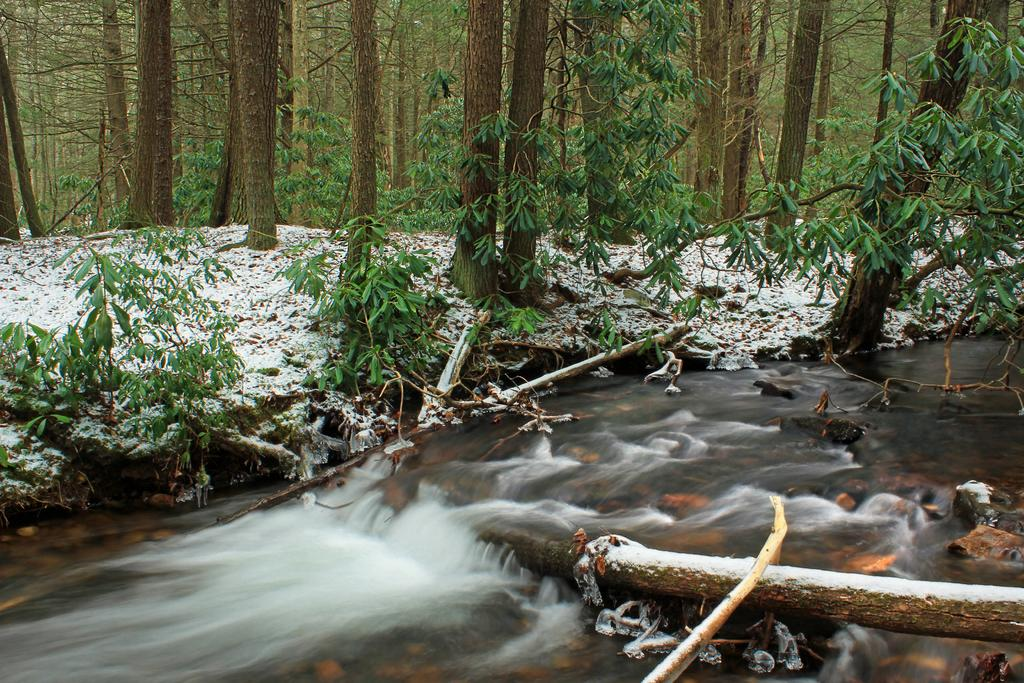What is the primary element visible in the image? There is water in the image. What type of natural environment can be seen in the image? There are woods and trees present in the image. What is the condition of the ground in the image? Snow is visible on the ground in the image. What type of steel structure can be seen in the image? There is no steel structure present in the image. How many dogs are visible in the image? There are no dogs visible in the image. 